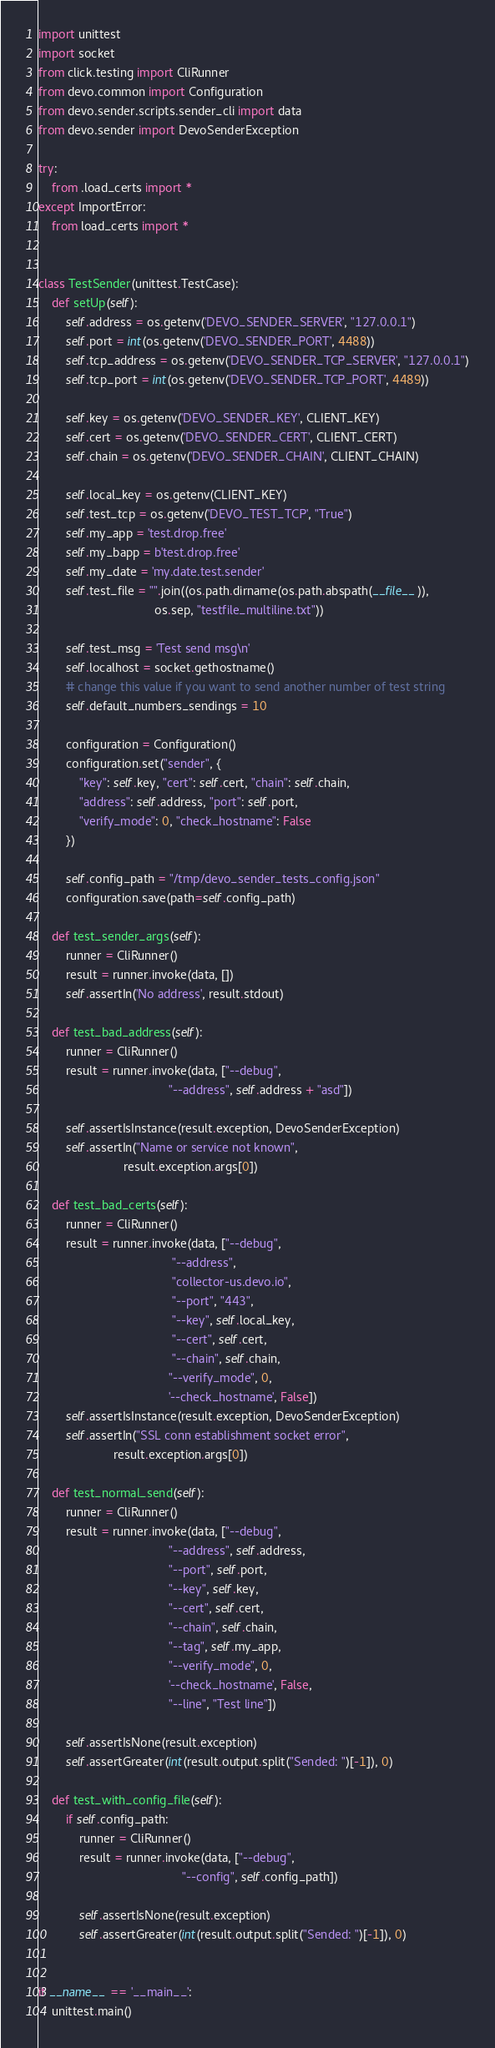<code> <loc_0><loc_0><loc_500><loc_500><_Python_>import unittest
import socket
from click.testing import CliRunner
from devo.common import Configuration
from devo.sender.scripts.sender_cli import data
from devo.sender import DevoSenderException

try:
    from .load_certs import *
except ImportError:
    from load_certs import *


class TestSender(unittest.TestCase):
    def setUp(self):
        self.address = os.getenv('DEVO_SENDER_SERVER', "127.0.0.1")
        self.port = int(os.getenv('DEVO_SENDER_PORT', 4488))
        self.tcp_address = os.getenv('DEVO_SENDER_TCP_SERVER', "127.0.0.1")
        self.tcp_port = int(os.getenv('DEVO_SENDER_TCP_PORT', 4489))

        self.key = os.getenv('DEVO_SENDER_KEY', CLIENT_KEY)
        self.cert = os.getenv('DEVO_SENDER_CERT', CLIENT_CERT)
        self.chain = os.getenv('DEVO_SENDER_CHAIN', CLIENT_CHAIN)

        self.local_key = os.getenv(CLIENT_KEY)
        self.test_tcp = os.getenv('DEVO_TEST_TCP', "True")
        self.my_app = 'test.drop.free'
        self.my_bapp = b'test.drop.free'
        self.my_date = 'my.date.test.sender'
        self.test_file = "".join((os.path.dirname(os.path.abspath(__file__)),
                                  os.sep, "testfile_multiline.txt"))

        self.test_msg = 'Test send msg\n'
        self.localhost = socket.gethostname()
        # change this value if you want to send another number of test string
        self.default_numbers_sendings = 10

        configuration = Configuration()
        configuration.set("sender", {
            "key": self.key, "cert": self.cert, "chain": self.chain,
            "address": self.address, "port": self.port,
            "verify_mode": 0, "check_hostname": False
        })

        self.config_path = "/tmp/devo_sender_tests_config.json"
        configuration.save(path=self.config_path)

    def test_sender_args(self):
        runner = CliRunner()
        result = runner.invoke(data, [])
        self.assertIn('No address', result.stdout)

    def test_bad_address(self):
        runner = CliRunner()
        result = runner.invoke(data, ["--debug",
                                      "--address", self.address + "asd"])

        self.assertIsInstance(result.exception, DevoSenderException)
        self.assertIn("Name or service not known",
                         result.exception.args[0])

    def test_bad_certs(self):
        runner = CliRunner()
        result = runner.invoke(data, ["--debug",
                                       "--address",
                                       "collector-us.devo.io",
                                       "--port", "443",
                                       "--key", self.local_key,
                                       "--cert", self.cert,
                                       "--chain", self.chain,
                                      "--verify_mode", 0,
                                      '--check_hostname', False])
        self.assertIsInstance(result.exception, DevoSenderException)
        self.assertIn("SSL conn establishment socket error",
                      result.exception.args[0])

    def test_normal_send(self):
        runner = CliRunner()
        result = runner.invoke(data, ["--debug",
                                      "--address", self.address,
                                      "--port", self.port,
                                      "--key", self.key,
                                      "--cert", self.cert,
                                      "--chain", self.chain,
                                      "--tag", self.my_app,
                                      "--verify_mode", 0,
                                      '--check_hostname', False,
                                      "--line", "Test line"])

        self.assertIsNone(result.exception)
        self.assertGreater(int(result.output.split("Sended: ")[-1]), 0)

    def test_with_config_file(self):
        if self.config_path:
            runner = CliRunner()
            result = runner.invoke(data, ["--debug",
                                          "--config", self.config_path])

            self.assertIsNone(result.exception)
            self.assertGreater(int(result.output.split("Sended: ")[-1]), 0)


if __name__ == '__main__':
    unittest.main()
</code> 